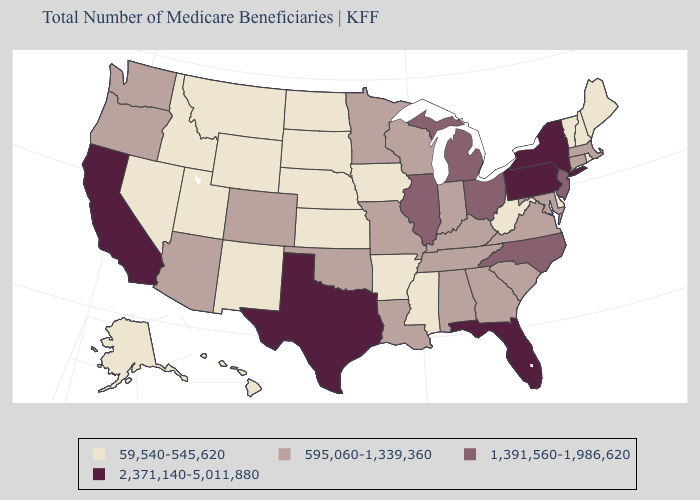Name the states that have a value in the range 595,060-1,339,360?
Concise answer only. Alabama, Arizona, Colorado, Connecticut, Georgia, Indiana, Kentucky, Louisiana, Maryland, Massachusetts, Minnesota, Missouri, Oklahoma, Oregon, South Carolina, Tennessee, Virginia, Washington, Wisconsin. Which states have the lowest value in the USA?
Be succinct. Alaska, Arkansas, Delaware, Hawaii, Idaho, Iowa, Kansas, Maine, Mississippi, Montana, Nebraska, Nevada, New Hampshire, New Mexico, North Dakota, Rhode Island, South Dakota, Utah, Vermont, West Virginia, Wyoming. Name the states that have a value in the range 1,391,560-1,986,620?
Answer briefly. Illinois, Michigan, New Jersey, North Carolina, Ohio. What is the highest value in the South ?
Short answer required. 2,371,140-5,011,880. What is the highest value in the USA?
Write a very short answer. 2,371,140-5,011,880. Does the first symbol in the legend represent the smallest category?
Answer briefly. Yes. What is the highest value in the South ?
Short answer required. 2,371,140-5,011,880. Which states have the highest value in the USA?
Concise answer only. California, Florida, New York, Pennsylvania, Texas. Which states hav the highest value in the Northeast?
Short answer required. New York, Pennsylvania. Among the states that border Mississippi , does Alabama have the highest value?
Quick response, please. Yes. Name the states that have a value in the range 2,371,140-5,011,880?
Keep it brief. California, Florida, New York, Pennsylvania, Texas. Among the states that border Georgia , which have the lowest value?
Give a very brief answer. Alabama, South Carolina, Tennessee. Is the legend a continuous bar?
Answer briefly. No. Name the states that have a value in the range 1,391,560-1,986,620?
Write a very short answer. Illinois, Michigan, New Jersey, North Carolina, Ohio. 